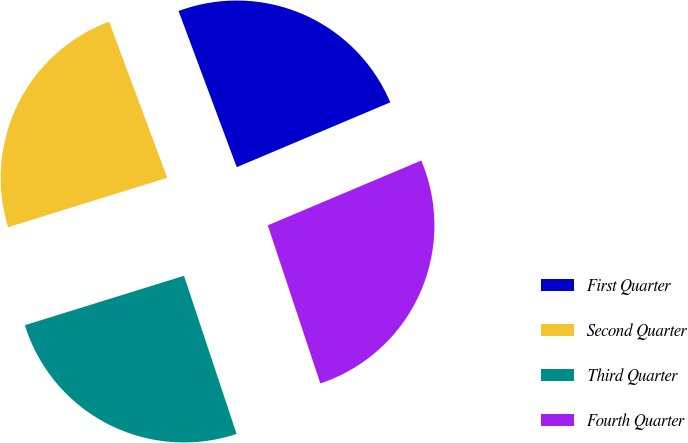Convert chart to OTSL. <chart><loc_0><loc_0><loc_500><loc_500><pie_chart><fcel>First Quarter<fcel>Second Quarter<fcel>Third Quarter<fcel>Fourth Quarter<nl><fcel>24.32%<fcel>24.11%<fcel>25.32%<fcel>26.25%<nl></chart> 